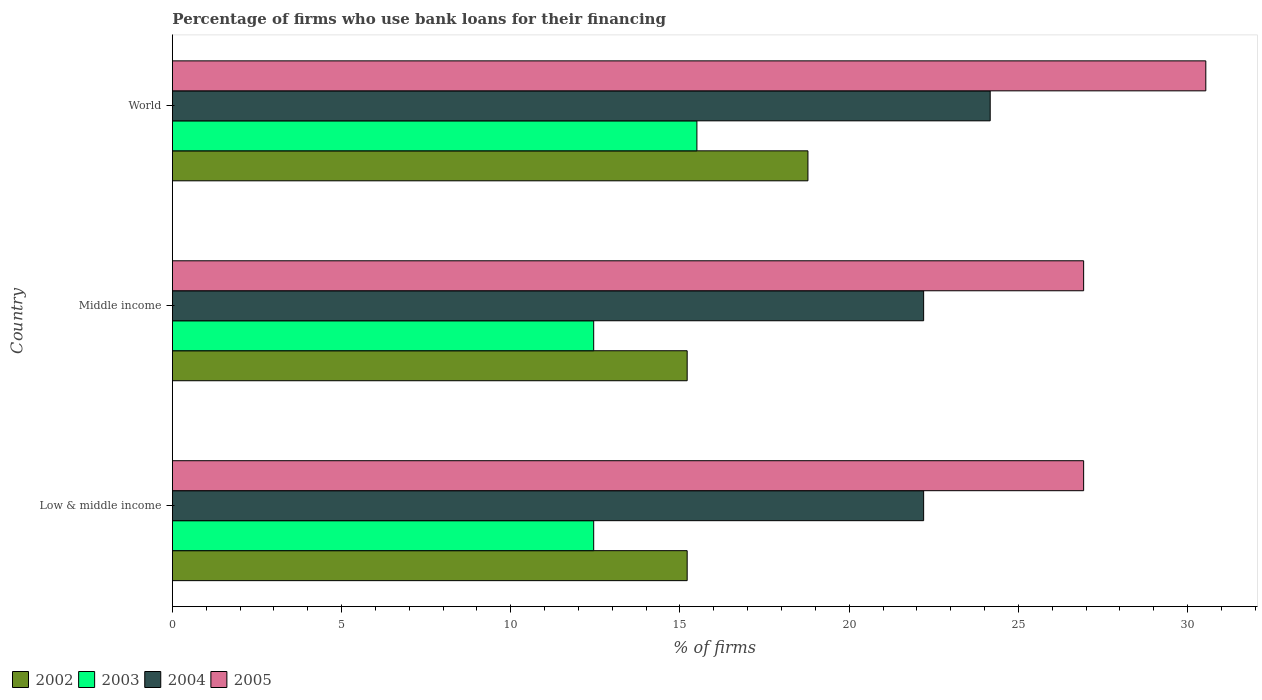How many different coloured bars are there?
Your response must be concise. 4. Are the number of bars on each tick of the Y-axis equal?
Keep it short and to the point. Yes. In how many cases, is the number of bars for a given country not equal to the number of legend labels?
Provide a short and direct response. 0. In which country was the percentage of firms who use bank loans for their financing in 2002 maximum?
Your answer should be very brief. World. What is the total percentage of firms who use bank loans for their financing in 2002 in the graph?
Offer a very short reply. 49.21. What is the difference between the percentage of firms who use bank loans for their financing in 2003 in Middle income and that in World?
Make the answer very short. -3.05. What is the difference between the percentage of firms who use bank loans for their financing in 2004 in World and the percentage of firms who use bank loans for their financing in 2003 in Low & middle income?
Offer a terse response. 11.72. What is the average percentage of firms who use bank loans for their financing in 2004 per country?
Your response must be concise. 22.86. What is the difference between the percentage of firms who use bank loans for their financing in 2002 and percentage of firms who use bank loans for their financing in 2004 in Middle income?
Your answer should be very brief. -6.99. In how many countries, is the percentage of firms who use bank loans for their financing in 2003 greater than 22 %?
Provide a short and direct response. 0. What is the ratio of the percentage of firms who use bank loans for their financing in 2002 in Low & middle income to that in Middle income?
Provide a short and direct response. 1. Is the percentage of firms who use bank loans for their financing in 2003 in Middle income less than that in World?
Your response must be concise. Yes. What is the difference between the highest and the second highest percentage of firms who use bank loans for their financing in 2005?
Offer a terse response. 3.61. What is the difference between the highest and the lowest percentage of firms who use bank loans for their financing in 2003?
Your answer should be very brief. 3.05. Is it the case that in every country, the sum of the percentage of firms who use bank loans for their financing in 2004 and percentage of firms who use bank loans for their financing in 2005 is greater than the sum of percentage of firms who use bank loans for their financing in 2003 and percentage of firms who use bank loans for their financing in 2002?
Offer a very short reply. Yes. What does the 4th bar from the top in Middle income represents?
Ensure brevity in your answer.  2002. How many bars are there?
Give a very brief answer. 12. Are all the bars in the graph horizontal?
Offer a very short reply. Yes. Are the values on the major ticks of X-axis written in scientific E-notation?
Keep it short and to the point. No. Does the graph contain grids?
Your answer should be compact. No. How many legend labels are there?
Your response must be concise. 4. What is the title of the graph?
Provide a short and direct response. Percentage of firms who use bank loans for their financing. Does "1976" appear as one of the legend labels in the graph?
Offer a very short reply. No. What is the label or title of the X-axis?
Ensure brevity in your answer.  % of firms. What is the label or title of the Y-axis?
Ensure brevity in your answer.  Country. What is the % of firms in 2002 in Low & middle income?
Offer a terse response. 15.21. What is the % of firms in 2003 in Low & middle income?
Your response must be concise. 12.45. What is the % of firms in 2004 in Low & middle income?
Make the answer very short. 22.2. What is the % of firms in 2005 in Low & middle income?
Offer a very short reply. 26.93. What is the % of firms of 2002 in Middle income?
Your answer should be compact. 15.21. What is the % of firms in 2003 in Middle income?
Provide a succinct answer. 12.45. What is the % of firms of 2004 in Middle income?
Your answer should be very brief. 22.2. What is the % of firms in 2005 in Middle income?
Keep it short and to the point. 26.93. What is the % of firms in 2002 in World?
Your response must be concise. 18.78. What is the % of firms in 2004 in World?
Provide a succinct answer. 24.17. What is the % of firms in 2005 in World?
Ensure brevity in your answer.  30.54. Across all countries, what is the maximum % of firms of 2002?
Provide a succinct answer. 18.78. Across all countries, what is the maximum % of firms in 2004?
Offer a very short reply. 24.17. Across all countries, what is the maximum % of firms in 2005?
Provide a succinct answer. 30.54. Across all countries, what is the minimum % of firms in 2002?
Provide a short and direct response. 15.21. Across all countries, what is the minimum % of firms in 2003?
Your answer should be very brief. 12.45. Across all countries, what is the minimum % of firms of 2005?
Your answer should be compact. 26.93. What is the total % of firms in 2002 in the graph?
Offer a very short reply. 49.21. What is the total % of firms of 2003 in the graph?
Keep it short and to the point. 40.4. What is the total % of firms of 2004 in the graph?
Keep it short and to the point. 68.57. What is the total % of firms of 2005 in the graph?
Provide a succinct answer. 84.39. What is the difference between the % of firms of 2002 in Low & middle income and that in Middle income?
Provide a short and direct response. 0. What is the difference between the % of firms of 2004 in Low & middle income and that in Middle income?
Ensure brevity in your answer.  0. What is the difference between the % of firms of 2002 in Low & middle income and that in World?
Provide a succinct answer. -3.57. What is the difference between the % of firms in 2003 in Low & middle income and that in World?
Make the answer very short. -3.05. What is the difference between the % of firms in 2004 in Low & middle income and that in World?
Offer a terse response. -1.97. What is the difference between the % of firms in 2005 in Low & middle income and that in World?
Your answer should be very brief. -3.61. What is the difference between the % of firms of 2002 in Middle income and that in World?
Keep it short and to the point. -3.57. What is the difference between the % of firms of 2003 in Middle income and that in World?
Make the answer very short. -3.05. What is the difference between the % of firms in 2004 in Middle income and that in World?
Provide a succinct answer. -1.97. What is the difference between the % of firms in 2005 in Middle income and that in World?
Make the answer very short. -3.61. What is the difference between the % of firms in 2002 in Low & middle income and the % of firms in 2003 in Middle income?
Offer a terse response. 2.76. What is the difference between the % of firms of 2002 in Low & middle income and the % of firms of 2004 in Middle income?
Ensure brevity in your answer.  -6.99. What is the difference between the % of firms of 2002 in Low & middle income and the % of firms of 2005 in Middle income?
Your answer should be very brief. -11.72. What is the difference between the % of firms in 2003 in Low & middle income and the % of firms in 2004 in Middle income?
Your response must be concise. -9.75. What is the difference between the % of firms of 2003 in Low & middle income and the % of firms of 2005 in Middle income?
Keep it short and to the point. -14.48. What is the difference between the % of firms of 2004 in Low & middle income and the % of firms of 2005 in Middle income?
Keep it short and to the point. -4.73. What is the difference between the % of firms of 2002 in Low & middle income and the % of firms of 2003 in World?
Give a very brief answer. -0.29. What is the difference between the % of firms in 2002 in Low & middle income and the % of firms in 2004 in World?
Give a very brief answer. -8.95. What is the difference between the % of firms of 2002 in Low & middle income and the % of firms of 2005 in World?
Your answer should be very brief. -15.33. What is the difference between the % of firms in 2003 in Low & middle income and the % of firms in 2004 in World?
Your response must be concise. -11.72. What is the difference between the % of firms of 2003 in Low & middle income and the % of firms of 2005 in World?
Ensure brevity in your answer.  -18.09. What is the difference between the % of firms of 2004 in Low & middle income and the % of firms of 2005 in World?
Provide a short and direct response. -8.34. What is the difference between the % of firms of 2002 in Middle income and the % of firms of 2003 in World?
Make the answer very short. -0.29. What is the difference between the % of firms in 2002 in Middle income and the % of firms in 2004 in World?
Your response must be concise. -8.95. What is the difference between the % of firms of 2002 in Middle income and the % of firms of 2005 in World?
Make the answer very short. -15.33. What is the difference between the % of firms in 2003 in Middle income and the % of firms in 2004 in World?
Your response must be concise. -11.72. What is the difference between the % of firms in 2003 in Middle income and the % of firms in 2005 in World?
Your answer should be compact. -18.09. What is the difference between the % of firms of 2004 in Middle income and the % of firms of 2005 in World?
Your answer should be compact. -8.34. What is the average % of firms in 2002 per country?
Offer a terse response. 16.4. What is the average % of firms in 2003 per country?
Offer a very short reply. 13.47. What is the average % of firms of 2004 per country?
Provide a short and direct response. 22.86. What is the average % of firms in 2005 per country?
Offer a terse response. 28.13. What is the difference between the % of firms of 2002 and % of firms of 2003 in Low & middle income?
Your answer should be very brief. 2.76. What is the difference between the % of firms of 2002 and % of firms of 2004 in Low & middle income?
Keep it short and to the point. -6.99. What is the difference between the % of firms of 2002 and % of firms of 2005 in Low & middle income?
Give a very brief answer. -11.72. What is the difference between the % of firms of 2003 and % of firms of 2004 in Low & middle income?
Your answer should be very brief. -9.75. What is the difference between the % of firms in 2003 and % of firms in 2005 in Low & middle income?
Your answer should be compact. -14.48. What is the difference between the % of firms in 2004 and % of firms in 2005 in Low & middle income?
Offer a very short reply. -4.73. What is the difference between the % of firms of 2002 and % of firms of 2003 in Middle income?
Your answer should be very brief. 2.76. What is the difference between the % of firms of 2002 and % of firms of 2004 in Middle income?
Offer a terse response. -6.99. What is the difference between the % of firms of 2002 and % of firms of 2005 in Middle income?
Ensure brevity in your answer.  -11.72. What is the difference between the % of firms in 2003 and % of firms in 2004 in Middle income?
Provide a short and direct response. -9.75. What is the difference between the % of firms in 2003 and % of firms in 2005 in Middle income?
Provide a succinct answer. -14.48. What is the difference between the % of firms in 2004 and % of firms in 2005 in Middle income?
Your response must be concise. -4.73. What is the difference between the % of firms of 2002 and % of firms of 2003 in World?
Provide a succinct answer. 3.28. What is the difference between the % of firms in 2002 and % of firms in 2004 in World?
Offer a terse response. -5.39. What is the difference between the % of firms of 2002 and % of firms of 2005 in World?
Provide a short and direct response. -11.76. What is the difference between the % of firms of 2003 and % of firms of 2004 in World?
Make the answer very short. -8.67. What is the difference between the % of firms in 2003 and % of firms in 2005 in World?
Provide a succinct answer. -15.04. What is the difference between the % of firms in 2004 and % of firms in 2005 in World?
Your response must be concise. -6.37. What is the ratio of the % of firms in 2002 in Low & middle income to that in Middle income?
Your answer should be compact. 1. What is the ratio of the % of firms of 2004 in Low & middle income to that in Middle income?
Provide a succinct answer. 1. What is the ratio of the % of firms of 2005 in Low & middle income to that in Middle income?
Offer a terse response. 1. What is the ratio of the % of firms of 2002 in Low & middle income to that in World?
Your answer should be compact. 0.81. What is the ratio of the % of firms of 2003 in Low & middle income to that in World?
Ensure brevity in your answer.  0.8. What is the ratio of the % of firms in 2004 in Low & middle income to that in World?
Provide a short and direct response. 0.92. What is the ratio of the % of firms of 2005 in Low & middle income to that in World?
Your response must be concise. 0.88. What is the ratio of the % of firms of 2002 in Middle income to that in World?
Your answer should be very brief. 0.81. What is the ratio of the % of firms of 2003 in Middle income to that in World?
Give a very brief answer. 0.8. What is the ratio of the % of firms of 2004 in Middle income to that in World?
Provide a succinct answer. 0.92. What is the ratio of the % of firms of 2005 in Middle income to that in World?
Your answer should be very brief. 0.88. What is the difference between the highest and the second highest % of firms in 2002?
Your answer should be very brief. 3.57. What is the difference between the highest and the second highest % of firms in 2003?
Ensure brevity in your answer.  3.05. What is the difference between the highest and the second highest % of firms in 2004?
Give a very brief answer. 1.97. What is the difference between the highest and the second highest % of firms of 2005?
Your answer should be very brief. 3.61. What is the difference between the highest and the lowest % of firms of 2002?
Keep it short and to the point. 3.57. What is the difference between the highest and the lowest % of firms in 2003?
Your answer should be compact. 3.05. What is the difference between the highest and the lowest % of firms in 2004?
Your response must be concise. 1.97. What is the difference between the highest and the lowest % of firms of 2005?
Make the answer very short. 3.61. 